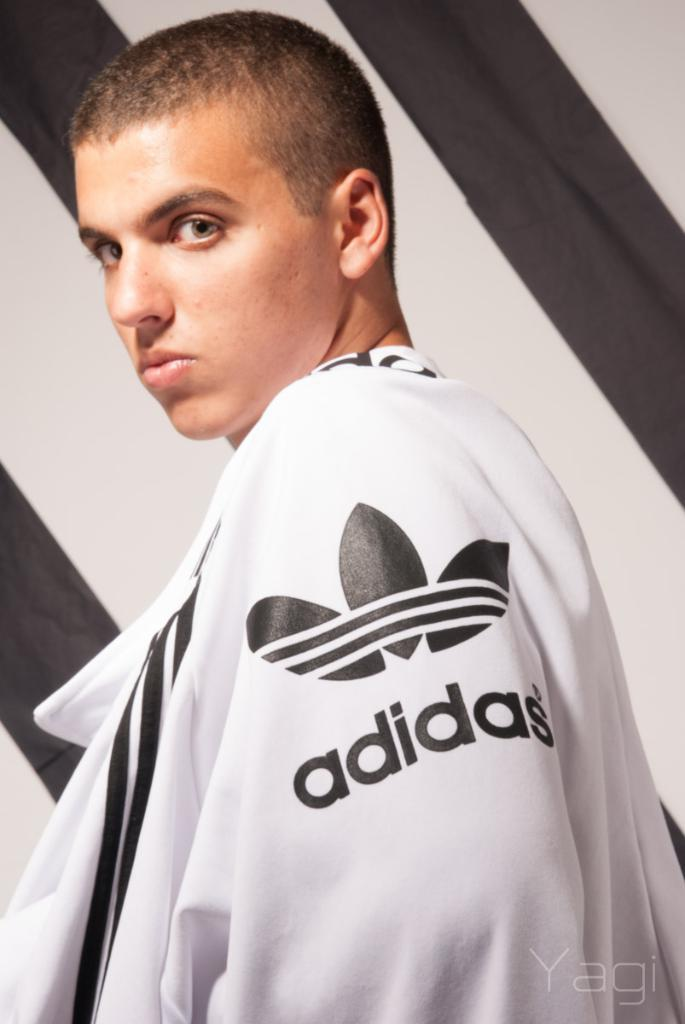<image>
Write a terse but informative summary of the picture. an adidas jersey on the person looking at the camera 